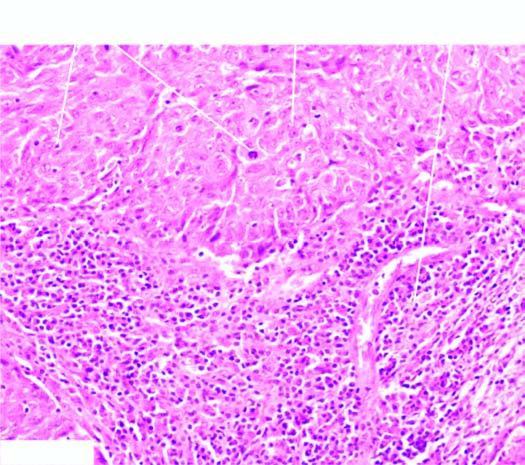what does microscopy show?
Answer the question using a single word or phrase. Two characteristic features-large tumour cells forming syncytial arrangement and stroma infiltrated richly with lymphocytes 